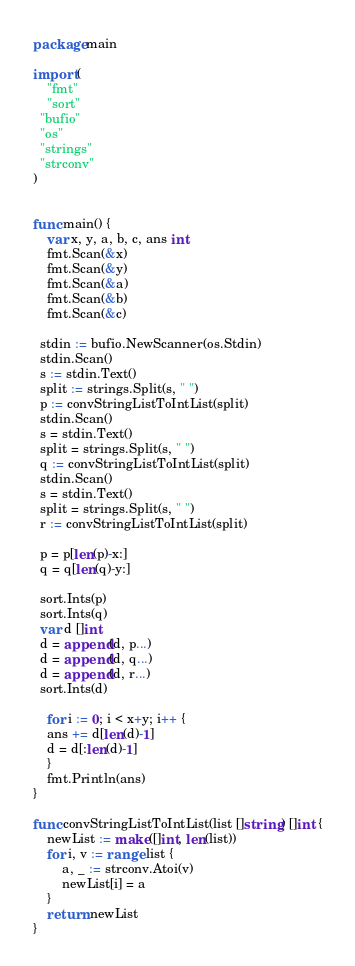<code> <loc_0><loc_0><loc_500><loc_500><_Go_>package main

import (
	"fmt"
	"sort"
  "bufio"
  "os"
  "strings"
  "strconv"
)


func main() {
	var x, y, a, b, c, ans int
	fmt.Scan(&x)
	fmt.Scan(&y)
	fmt.Scan(&a)
	fmt.Scan(&b)
	fmt.Scan(&c)

  stdin := bufio.NewScanner(os.Stdin)
  stdin.Scan()
  s := stdin.Text()
  split := strings.Split(s, " ")
  p := convStringListToIntList(split)
  stdin.Scan()
  s = stdin.Text()
  split = strings.Split(s, " ")
  q := convStringListToIntList(split)
  stdin.Scan()
  s = stdin.Text()
  split = strings.Split(s, " ")
  r := convStringListToIntList(split)

  p = p[len(p)-x:]
  q = q[len(q)-y:]

  sort.Ints(p)
  sort.Ints(q)
  var d []int
  d = append(d, p...)
  d = append(d, q...)
  d = append(d, r...)
  sort.Ints(d)

	for i := 0; i < x+y; i++ {
    ans += d[len(d)-1]
    d = d[:len(d)-1]
	}
	fmt.Println(ans)
}

func convStringListToIntList(list []string) []int {
    newList := make([]int, len(list))
    for i, v := range list {
        a, _ := strconv.Atoi(v)
        newList[i] = a
    }
    return newList
}
</code> 